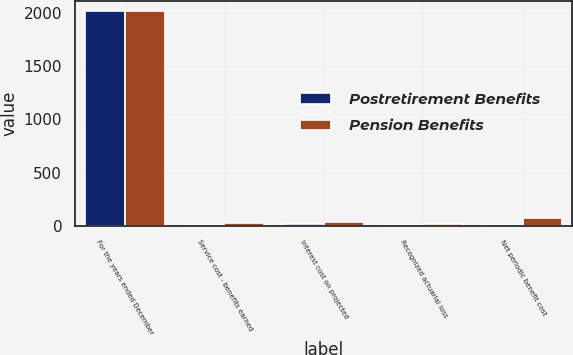<chart> <loc_0><loc_0><loc_500><loc_500><stacked_bar_chart><ecel><fcel>For the years ended December<fcel>Service cost - benefits earned<fcel>Interest cost on projected<fcel>Recognized actuarial loss<fcel>Net periodic benefit cost<nl><fcel>Postretirement Benefits<fcel>2018<fcel>5<fcel>15<fcel>7<fcel>3<nl><fcel>Pension Benefits<fcel>2018<fcel>23<fcel>34<fcel>14<fcel>69<nl></chart> 